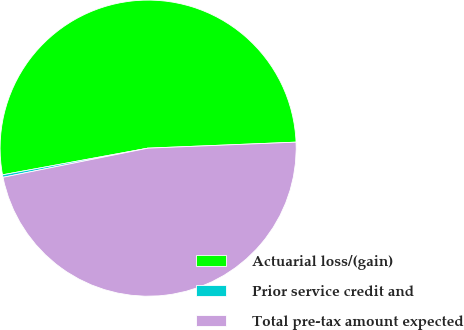<chart> <loc_0><loc_0><loc_500><loc_500><pie_chart><fcel>Actuarial loss/(gain)<fcel>Prior service credit and<fcel>Total pre-tax amount expected<nl><fcel>52.24%<fcel>0.27%<fcel>47.49%<nl></chart> 